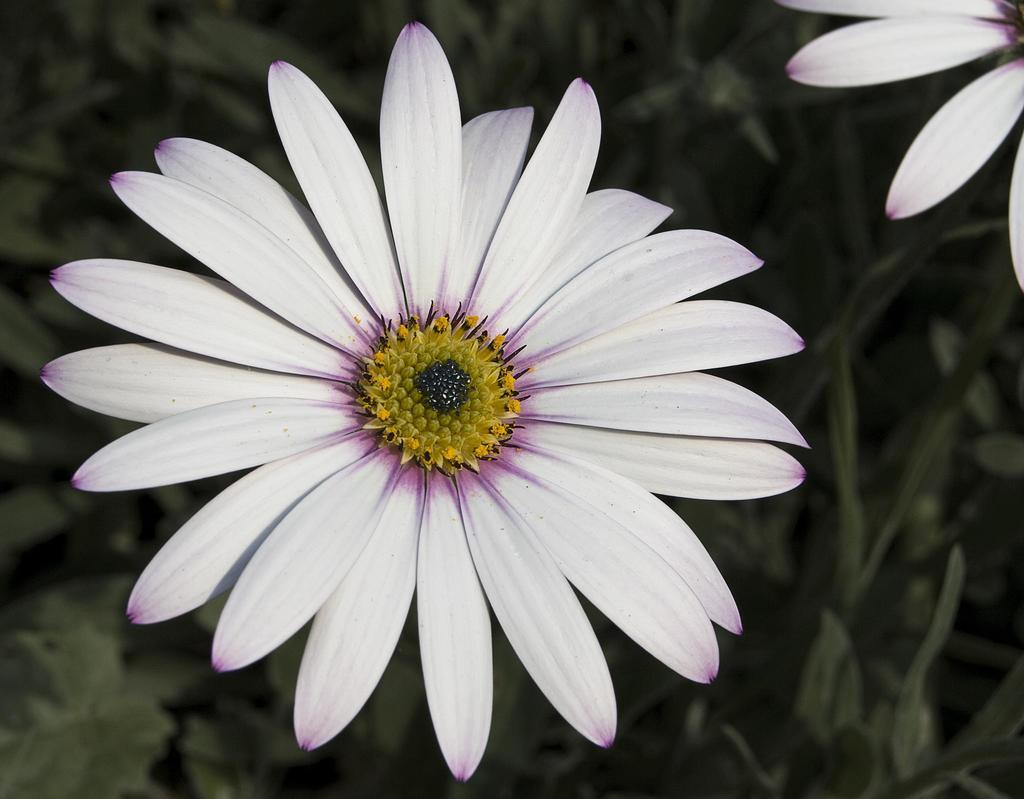What type of living organisms can be seen in the image? There are flowers in the image. What can be seen in the background of the image? There are plants in the background of the image. What disease is the fireman treating in the image? There is no fireman or disease present in the image; it features flowers and plants. 